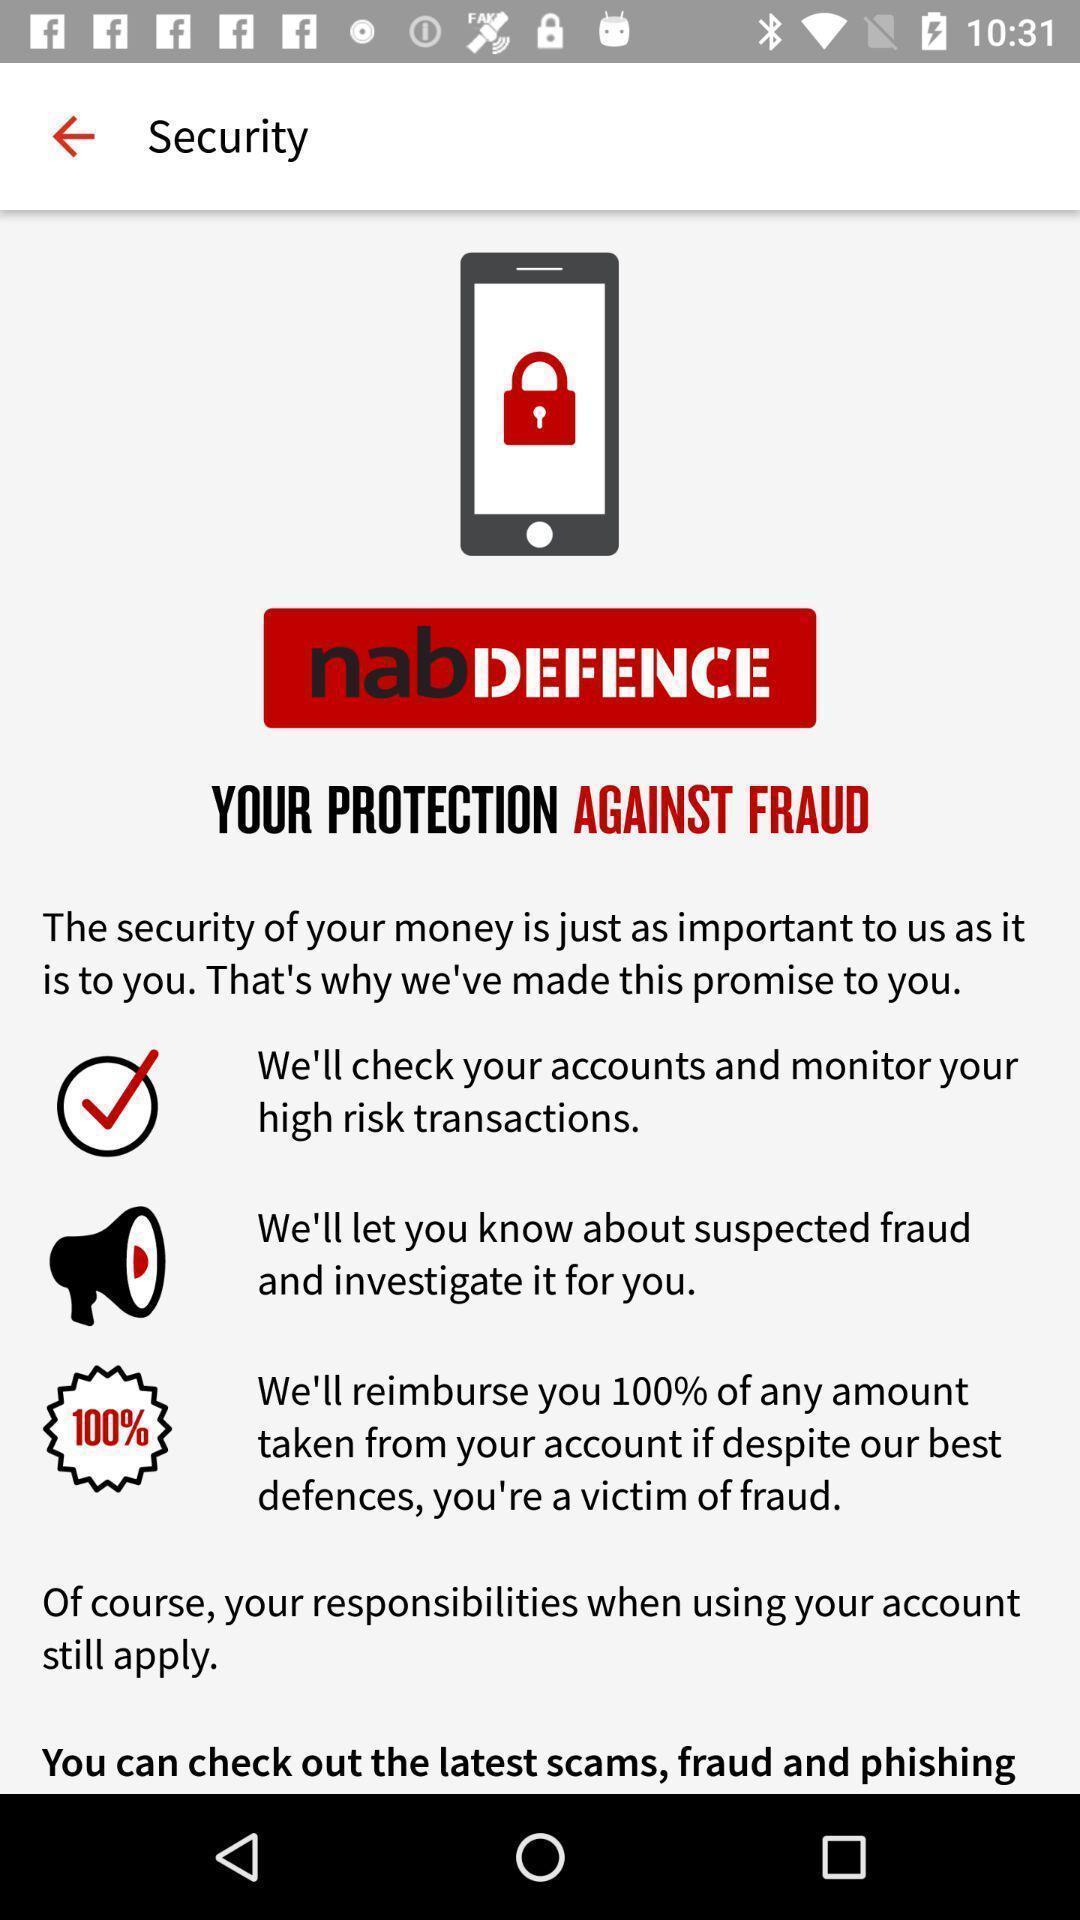Provide a description of this screenshot. Social app showing list of security. 